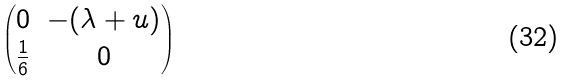Convert formula to latex. <formula><loc_0><loc_0><loc_500><loc_500>\begin{pmatrix} 0 & - ( \lambda + u ) \\ \frac { 1 } { 6 } & 0 \end{pmatrix}</formula> 